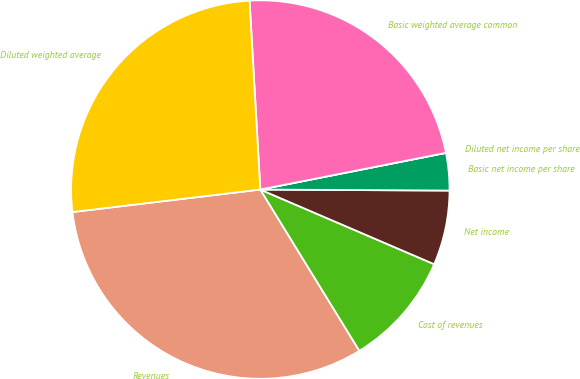<chart> <loc_0><loc_0><loc_500><loc_500><pie_chart><fcel>Revenues<fcel>Cost of revenues<fcel>Net income<fcel>Basic net income per share<fcel>Diluted net income per share<fcel>Basic weighted average common<fcel>Diluted weighted average<nl><fcel>31.87%<fcel>9.78%<fcel>6.37%<fcel>3.19%<fcel>0.0%<fcel>22.8%<fcel>25.99%<nl></chart> 